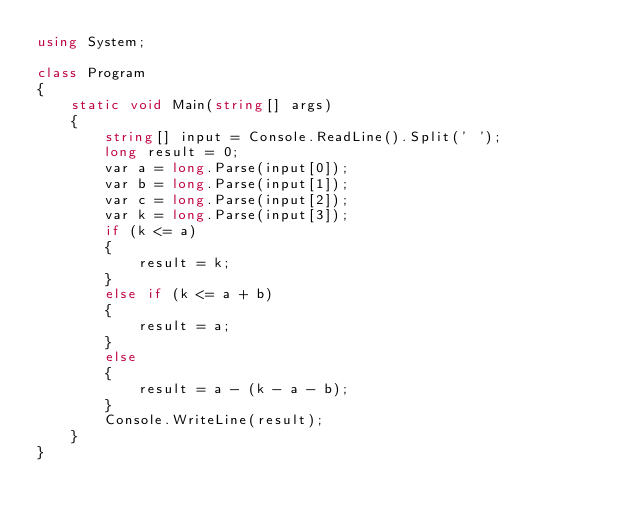Convert code to text. <code><loc_0><loc_0><loc_500><loc_500><_C#_>using System;

class Program
{
    static void Main(string[] args)
    {
        string[] input = Console.ReadLine().Split(' ');
        long result = 0;
        var a = long.Parse(input[0]);
        var b = long.Parse(input[1]);
        var c = long.Parse(input[2]);
        var k = long.Parse(input[3]);
        if (k <= a)
        {
            result = k;
        }
        else if (k <= a + b)
        {
            result = a;
        }
        else
        {
            result = a - (k - a - b);
        }
        Console.WriteLine(result);
    }
}</code> 